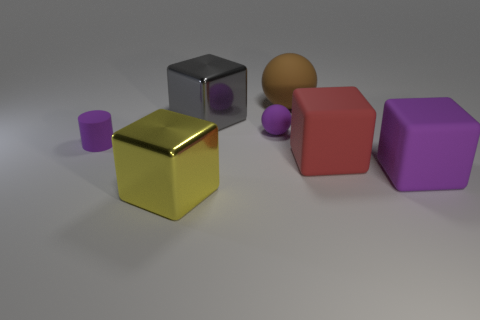There is a rubber sphere that is to the left of the rubber thing behind the matte ball that is in front of the brown object; what is its size? The rubber sphere to the left of the second rubber object, placed behind the matte ball and in front of the brown object, appears to be of a small size, approximately equivalent to the size of a standard ping-pong ball. 